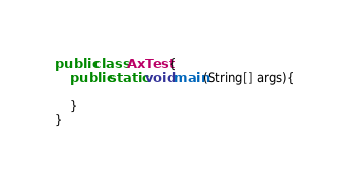Convert code to text. <code><loc_0><loc_0><loc_500><loc_500><_Java_>
public class AxTest {
	public static void main(String[] args){
		
	}
}
</code> 